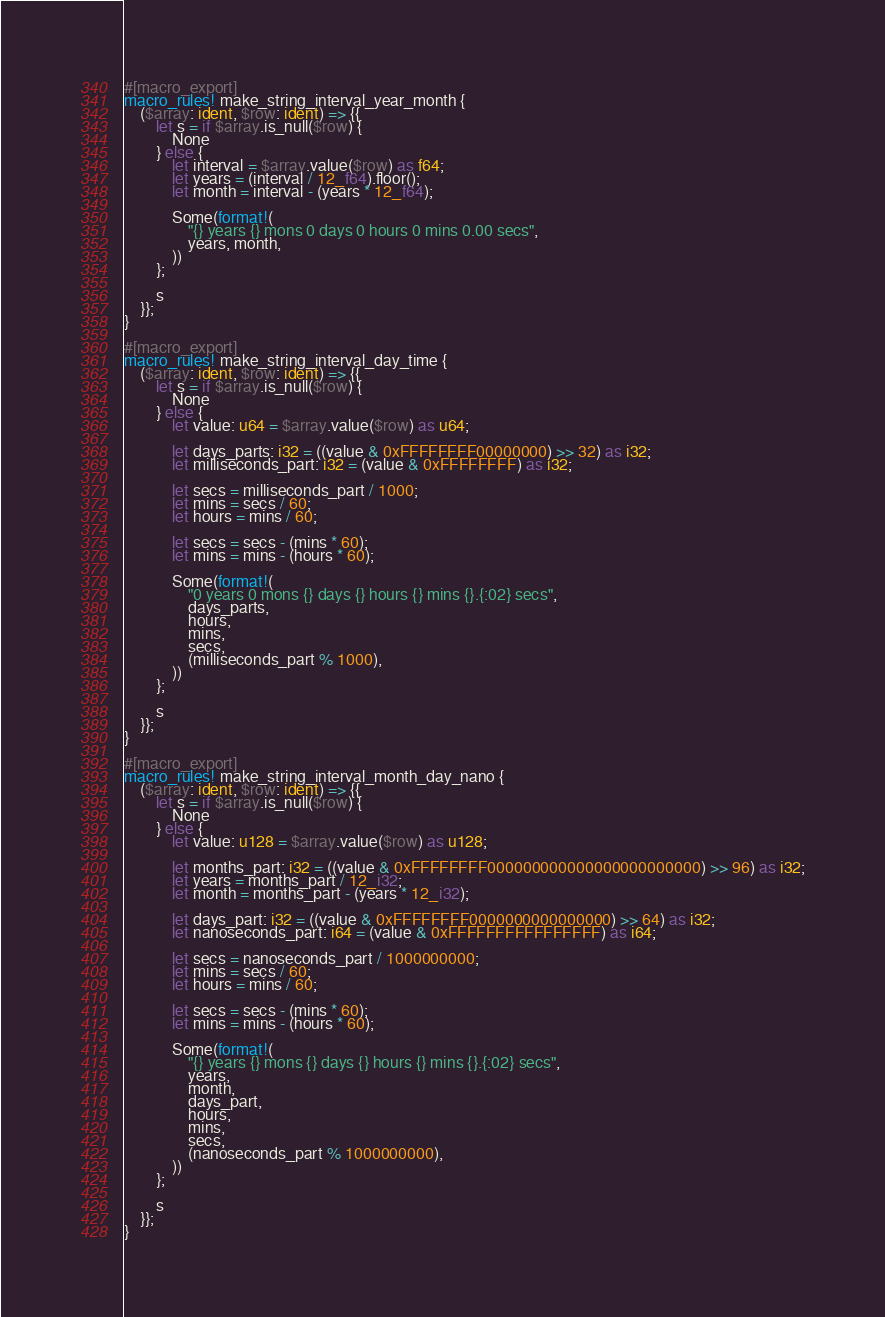Convert code to text. <code><loc_0><loc_0><loc_500><loc_500><_Rust_>#[macro_export]
macro_rules! make_string_interval_year_month {
    ($array: ident, $row: ident) => {{
        let s = if $array.is_null($row) {
            None
        } else {
            let interval = $array.value($row) as f64;
            let years = (interval / 12_f64).floor();
            let month = interval - (years * 12_f64);

            Some(format!(
                "{} years {} mons 0 days 0 hours 0 mins 0.00 secs",
                years, month,
            ))
        };

        s
    }};
}

#[macro_export]
macro_rules! make_string_interval_day_time {
    ($array: ident, $row: ident) => {{
        let s = if $array.is_null($row) {
            None
        } else {
            let value: u64 = $array.value($row) as u64;

            let days_parts: i32 = ((value & 0xFFFFFFFF00000000) >> 32) as i32;
            let milliseconds_part: i32 = (value & 0xFFFFFFFF) as i32;

            let secs = milliseconds_part / 1000;
            let mins = secs / 60;
            let hours = mins / 60;

            let secs = secs - (mins * 60);
            let mins = mins - (hours * 60);

            Some(format!(
                "0 years 0 mons {} days {} hours {} mins {}.{:02} secs",
                days_parts,
                hours,
                mins,
                secs,
                (milliseconds_part % 1000),
            ))
        };

        s
    }};
}

#[macro_export]
macro_rules! make_string_interval_month_day_nano {
    ($array: ident, $row: ident) => {{
        let s = if $array.is_null($row) {
            None
        } else {
            let value: u128 = $array.value($row) as u128;

            let months_part: i32 = ((value & 0xFFFFFFFF000000000000000000000000) >> 96) as i32;
            let years = months_part / 12_i32;
            let month = months_part - (years * 12_i32);

            let days_part: i32 = ((value & 0xFFFFFFFF0000000000000000) >> 64) as i32;
            let nanoseconds_part: i64 = (value & 0xFFFFFFFFFFFFFFFF) as i64;

            let secs = nanoseconds_part / 1000000000;
            let mins = secs / 60;
            let hours = mins / 60;

            let secs = secs - (mins * 60);
            let mins = mins - (hours * 60);

            Some(format!(
                "{} years {} mons {} days {} hours {} mins {}.{:02} secs",
                years,
                month,
                days_part,
                hours,
                mins,
                secs,
                (nanoseconds_part % 1000000000),
            ))
        };

        s
    }};
}
</code> 